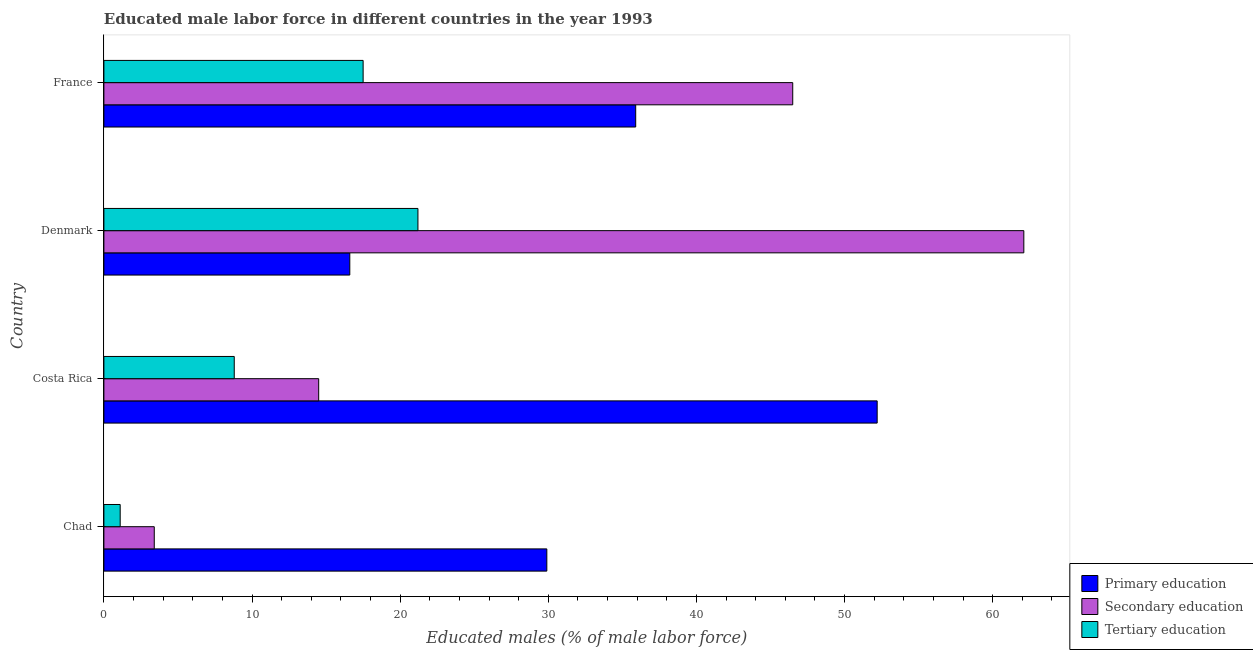How many different coloured bars are there?
Offer a terse response. 3. How many groups of bars are there?
Offer a terse response. 4. Are the number of bars per tick equal to the number of legend labels?
Your response must be concise. Yes. What is the percentage of male labor force who received secondary education in Chad?
Provide a short and direct response. 3.4. Across all countries, what is the maximum percentage of male labor force who received primary education?
Give a very brief answer. 52.2. Across all countries, what is the minimum percentage of male labor force who received secondary education?
Keep it short and to the point. 3.4. In which country was the percentage of male labor force who received tertiary education maximum?
Make the answer very short. Denmark. In which country was the percentage of male labor force who received tertiary education minimum?
Provide a short and direct response. Chad. What is the total percentage of male labor force who received tertiary education in the graph?
Your answer should be very brief. 48.6. What is the difference between the percentage of male labor force who received tertiary education in Chad and that in Denmark?
Provide a succinct answer. -20.1. What is the difference between the percentage of male labor force who received secondary education in Chad and the percentage of male labor force who received primary education in Denmark?
Offer a terse response. -13.2. What is the average percentage of male labor force who received secondary education per country?
Offer a very short reply. 31.62. What is the difference between the percentage of male labor force who received primary education and percentage of male labor force who received secondary education in Chad?
Keep it short and to the point. 26.5. What is the ratio of the percentage of male labor force who received primary education in Costa Rica to that in Denmark?
Offer a very short reply. 3.15. Is the difference between the percentage of male labor force who received tertiary education in Costa Rica and France greater than the difference between the percentage of male labor force who received primary education in Costa Rica and France?
Provide a short and direct response. No. What is the difference between the highest and the lowest percentage of male labor force who received secondary education?
Give a very brief answer. 58.7. In how many countries, is the percentage of male labor force who received tertiary education greater than the average percentage of male labor force who received tertiary education taken over all countries?
Ensure brevity in your answer.  2. Is the sum of the percentage of male labor force who received primary education in Denmark and France greater than the maximum percentage of male labor force who received secondary education across all countries?
Your answer should be very brief. No. What does the 1st bar from the top in France represents?
Provide a short and direct response. Tertiary education. What does the 2nd bar from the bottom in France represents?
Your answer should be compact. Secondary education. Is it the case that in every country, the sum of the percentage of male labor force who received primary education and percentage of male labor force who received secondary education is greater than the percentage of male labor force who received tertiary education?
Offer a terse response. Yes. Are all the bars in the graph horizontal?
Offer a terse response. Yes. How many countries are there in the graph?
Offer a very short reply. 4. Are the values on the major ticks of X-axis written in scientific E-notation?
Give a very brief answer. No. Does the graph contain any zero values?
Offer a terse response. No. Does the graph contain grids?
Give a very brief answer. No. Where does the legend appear in the graph?
Your answer should be compact. Bottom right. How many legend labels are there?
Offer a terse response. 3. How are the legend labels stacked?
Your answer should be compact. Vertical. What is the title of the graph?
Offer a very short reply. Educated male labor force in different countries in the year 1993. Does "Agriculture" appear as one of the legend labels in the graph?
Give a very brief answer. No. What is the label or title of the X-axis?
Ensure brevity in your answer.  Educated males (% of male labor force). What is the label or title of the Y-axis?
Your answer should be compact. Country. What is the Educated males (% of male labor force) of Primary education in Chad?
Provide a short and direct response. 29.9. What is the Educated males (% of male labor force) in Secondary education in Chad?
Offer a terse response. 3.4. What is the Educated males (% of male labor force) of Tertiary education in Chad?
Ensure brevity in your answer.  1.1. What is the Educated males (% of male labor force) in Primary education in Costa Rica?
Keep it short and to the point. 52.2. What is the Educated males (% of male labor force) in Tertiary education in Costa Rica?
Make the answer very short. 8.8. What is the Educated males (% of male labor force) in Primary education in Denmark?
Make the answer very short. 16.6. What is the Educated males (% of male labor force) in Secondary education in Denmark?
Provide a short and direct response. 62.1. What is the Educated males (% of male labor force) of Tertiary education in Denmark?
Your answer should be compact. 21.2. What is the Educated males (% of male labor force) in Primary education in France?
Keep it short and to the point. 35.9. What is the Educated males (% of male labor force) of Secondary education in France?
Keep it short and to the point. 46.5. What is the Educated males (% of male labor force) in Tertiary education in France?
Keep it short and to the point. 17.5. Across all countries, what is the maximum Educated males (% of male labor force) of Primary education?
Provide a short and direct response. 52.2. Across all countries, what is the maximum Educated males (% of male labor force) in Secondary education?
Provide a succinct answer. 62.1. Across all countries, what is the maximum Educated males (% of male labor force) in Tertiary education?
Provide a short and direct response. 21.2. Across all countries, what is the minimum Educated males (% of male labor force) of Primary education?
Your response must be concise. 16.6. Across all countries, what is the minimum Educated males (% of male labor force) of Secondary education?
Give a very brief answer. 3.4. Across all countries, what is the minimum Educated males (% of male labor force) in Tertiary education?
Your response must be concise. 1.1. What is the total Educated males (% of male labor force) in Primary education in the graph?
Your response must be concise. 134.6. What is the total Educated males (% of male labor force) of Secondary education in the graph?
Offer a terse response. 126.5. What is the total Educated males (% of male labor force) in Tertiary education in the graph?
Give a very brief answer. 48.6. What is the difference between the Educated males (% of male labor force) in Primary education in Chad and that in Costa Rica?
Ensure brevity in your answer.  -22.3. What is the difference between the Educated males (% of male labor force) in Secondary education in Chad and that in Costa Rica?
Provide a succinct answer. -11.1. What is the difference between the Educated males (% of male labor force) in Secondary education in Chad and that in Denmark?
Offer a terse response. -58.7. What is the difference between the Educated males (% of male labor force) of Tertiary education in Chad and that in Denmark?
Your answer should be compact. -20.1. What is the difference between the Educated males (% of male labor force) of Primary education in Chad and that in France?
Your answer should be very brief. -6. What is the difference between the Educated males (% of male labor force) in Secondary education in Chad and that in France?
Provide a short and direct response. -43.1. What is the difference between the Educated males (% of male labor force) of Tertiary education in Chad and that in France?
Keep it short and to the point. -16.4. What is the difference between the Educated males (% of male labor force) in Primary education in Costa Rica and that in Denmark?
Your response must be concise. 35.6. What is the difference between the Educated males (% of male labor force) of Secondary education in Costa Rica and that in Denmark?
Provide a succinct answer. -47.6. What is the difference between the Educated males (% of male labor force) in Secondary education in Costa Rica and that in France?
Provide a succinct answer. -32. What is the difference between the Educated males (% of male labor force) in Primary education in Denmark and that in France?
Your answer should be very brief. -19.3. What is the difference between the Educated males (% of male labor force) of Primary education in Chad and the Educated males (% of male labor force) of Secondary education in Costa Rica?
Make the answer very short. 15.4. What is the difference between the Educated males (% of male labor force) in Primary education in Chad and the Educated males (% of male labor force) in Tertiary education in Costa Rica?
Make the answer very short. 21.1. What is the difference between the Educated males (% of male labor force) in Secondary education in Chad and the Educated males (% of male labor force) in Tertiary education in Costa Rica?
Give a very brief answer. -5.4. What is the difference between the Educated males (% of male labor force) in Primary education in Chad and the Educated males (% of male labor force) in Secondary education in Denmark?
Provide a short and direct response. -32.2. What is the difference between the Educated males (% of male labor force) in Secondary education in Chad and the Educated males (% of male labor force) in Tertiary education in Denmark?
Provide a short and direct response. -17.8. What is the difference between the Educated males (% of male labor force) of Primary education in Chad and the Educated males (% of male labor force) of Secondary education in France?
Make the answer very short. -16.6. What is the difference between the Educated males (% of male labor force) of Primary education in Chad and the Educated males (% of male labor force) of Tertiary education in France?
Offer a very short reply. 12.4. What is the difference between the Educated males (% of male labor force) in Secondary education in Chad and the Educated males (% of male labor force) in Tertiary education in France?
Keep it short and to the point. -14.1. What is the difference between the Educated males (% of male labor force) of Primary education in Costa Rica and the Educated males (% of male labor force) of Secondary education in Denmark?
Ensure brevity in your answer.  -9.9. What is the difference between the Educated males (% of male labor force) of Secondary education in Costa Rica and the Educated males (% of male labor force) of Tertiary education in Denmark?
Provide a succinct answer. -6.7. What is the difference between the Educated males (% of male labor force) in Primary education in Costa Rica and the Educated males (% of male labor force) in Tertiary education in France?
Make the answer very short. 34.7. What is the difference between the Educated males (% of male labor force) in Primary education in Denmark and the Educated males (% of male labor force) in Secondary education in France?
Your answer should be compact. -29.9. What is the difference between the Educated males (% of male labor force) of Secondary education in Denmark and the Educated males (% of male labor force) of Tertiary education in France?
Ensure brevity in your answer.  44.6. What is the average Educated males (% of male labor force) of Primary education per country?
Your answer should be very brief. 33.65. What is the average Educated males (% of male labor force) of Secondary education per country?
Your response must be concise. 31.62. What is the average Educated males (% of male labor force) in Tertiary education per country?
Give a very brief answer. 12.15. What is the difference between the Educated males (% of male labor force) of Primary education and Educated males (% of male labor force) of Tertiary education in Chad?
Provide a succinct answer. 28.8. What is the difference between the Educated males (% of male labor force) in Secondary education and Educated males (% of male labor force) in Tertiary education in Chad?
Your answer should be very brief. 2.3. What is the difference between the Educated males (% of male labor force) of Primary education and Educated males (% of male labor force) of Secondary education in Costa Rica?
Make the answer very short. 37.7. What is the difference between the Educated males (% of male labor force) in Primary education and Educated males (% of male labor force) in Tertiary education in Costa Rica?
Ensure brevity in your answer.  43.4. What is the difference between the Educated males (% of male labor force) of Primary education and Educated males (% of male labor force) of Secondary education in Denmark?
Your response must be concise. -45.5. What is the difference between the Educated males (% of male labor force) of Primary education and Educated males (% of male labor force) of Tertiary education in Denmark?
Ensure brevity in your answer.  -4.6. What is the difference between the Educated males (% of male labor force) in Secondary education and Educated males (% of male labor force) in Tertiary education in Denmark?
Offer a very short reply. 40.9. What is the difference between the Educated males (% of male labor force) in Primary education and Educated males (% of male labor force) in Tertiary education in France?
Offer a terse response. 18.4. What is the ratio of the Educated males (% of male labor force) of Primary education in Chad to that in Costa Rica?
Your answer should be compact. 0.57. What is the ratio of the Educated males (% of male labor force) in Secondary education in Chad to that in Costa Rica?
Ensure brevity in your answer.  0.23. What is the ratio of the Educated males (% of male labor force) of Primary education in Chad to that in Denmark?
Keep it short and to the point. 1.8. What is the ratio of the Educated males (% of male labor force) in Secondary education in Chad to that in Denmark?
Your answer should be compact. 0.05. What is the ratio of the Educated males (% of male labor force) in Tertiary education in Chad to that in Denmark?
Your answer should be compact. 0.05. What is the ratio of the Educated males (% of male labor force) of Primary education in Chad to that in France?
Your answer should be compact. 0.83. What is the ratio of the Educated males (% of male labor force) of Secondary education in Chad to that in France?
Your answer should be very brief. 0.07. What is the ratio of the Educated males (% of male labor force) in Tertiary education in Chad to that in France?
Give a very brief answer. 0.06. What is the ratio of the Educated males (% of male labor force) in Primary education in Costa Rica to that in Denmark?
Offer a very short reply. 3.14. What is the ratio of the Educated males (% of male labor force) in Secondary education in Costa Rica to that in Denmark?
Your answer should be compact. 0.23. What is the ratio of the Educated males (% of male labor force) of Tertiary education in Costa Rica to that in Denmark?
Give a very brief answer. 0.42. What is the ratio of the Educated males (% of male labor force) in Primary education in Costa Rica to that in France?
Offer a terse response. 1.45. What is the ratio of the Educated males (% of male labor force) in Secondary education in Costa Rica to that in France?
Provide a short and direct response. 0.31. What is the ratio of the Educated males (% of male labor force) of Tertiary education in Costa Rica to that in France?
Give a very brief answer. 0.5. What is the ratio of the Educated males (% of male labor force) of Primary education in Denmark to that in France?
Give a very brief answer. 0.46. What is the ratio of the Educated males (% of male labor force) in Secondary education in Denmark to that in France?
Your response must be concise. 1.34. What is the ratio of the Educated males (% of male labor force) in Tertiary education in Denmark to that in France?
Offer a terse response. 1.21. What is the difference between the highest and the second highest Educated males (% of male labor force) of Primary education?
Keep it short and to the point. 16.3. What is the difference between the highest and the second highest Educated males (% of male labor force) of Secondary education?
Make the answer very short. 15.6. What is the difference between the highest and the second highest Educated males (% of male labor force) of Tertiary education?
Give a very brief answer. 3.7. What is the difference between the highest and the lowest Educated males (% of male labor force) in Primary education?
Keep it short and to the point. 35.6. What is the difference between the highest and the lowest Educated males (% of male labor force) of Secondary education?
Offer a terse response. 58.7. What is the difference between the highest and the lowest Educated males (% of male labor force) in Tertiary education?
Offer a very short reply. 20.1. 